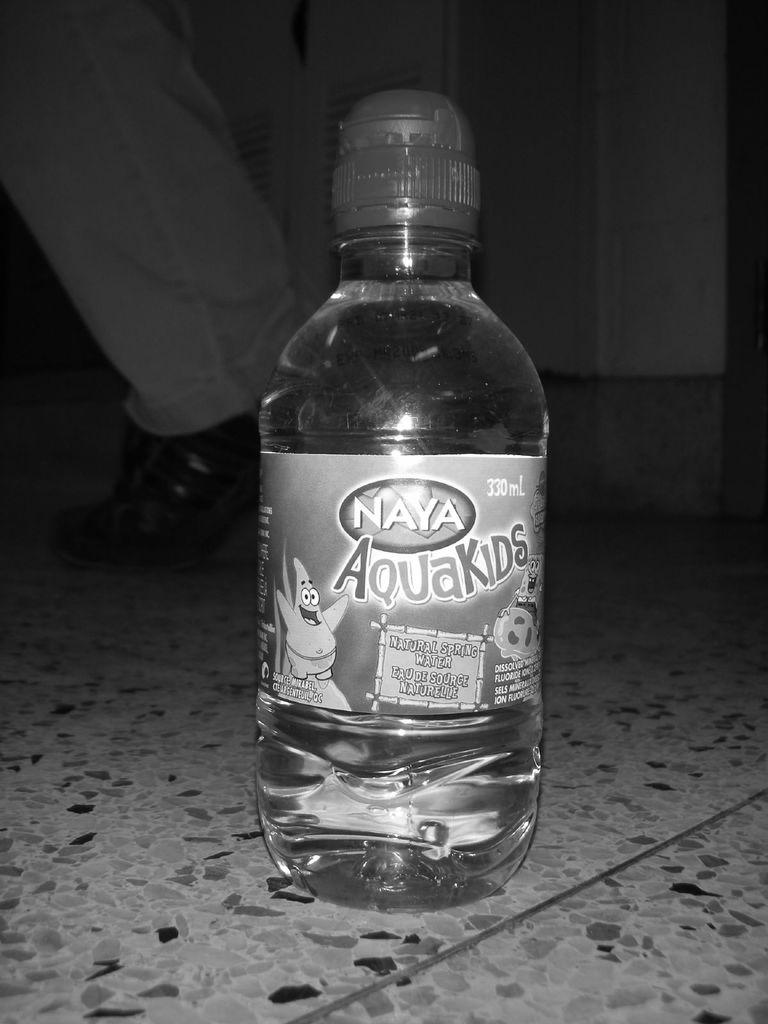Provide a one-sentence caption for the provided image. A bottle of Naya Aquakids sits on the floor. 